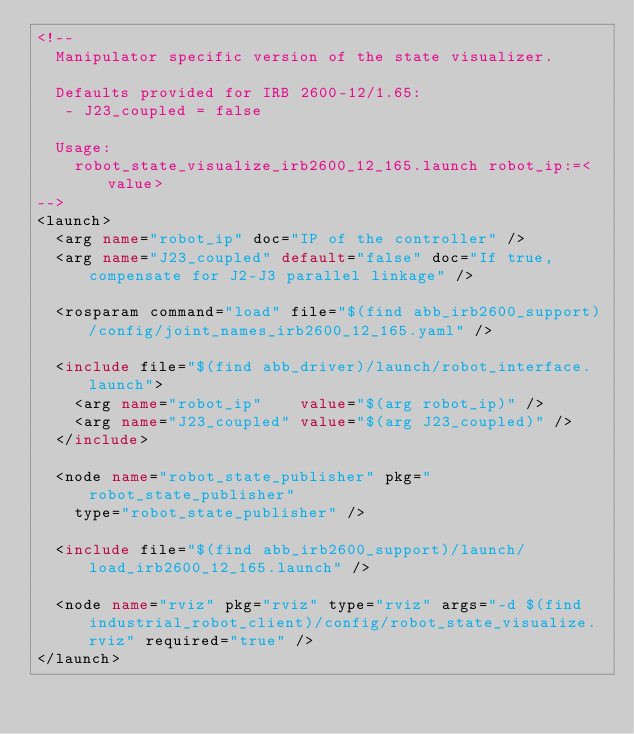<code> <loc_0><loc_0><loc_500><loc_500><_XML_><!--
  Manipulator specific version of the state visualizer.

  Defaults provided for IRB 2600-12/1.65:
   - J23_coupled = false

  Usage:
    robot_state_visualize_irb2600_12_165.launch robot_ip:=<value>
-->
<launch>
  <arg name="robot_ip" doc="IP of the controller" />
  <arg name="J23_coupled" default="false" doc="If true, compensate for J2-J3 parallel linkage" />

  <rosparam command="load" file="$(find abb_irb2600_support)/config/joint_names_irb2600_12_165.yaml" />

  <include file="$(find abb_driver)/launch/robot_interface.launch">
    <arg name="robot_ip"    value="$(arg robot_ip)" />
    <arg name="J23_coupled" value="$(arg J23_coupled)" />
  </include>

  <node name="robot_state_publisher" pkg="robot_state_publisher"
    type="robot_state_publisher" />

  <include file="$(find abb_irb2600_support)/launch/load_irb2600_12_165.launch" />

  <node name="rviz" pkg="rviz" type="rviz" args="-d $(find industrial_robot_client)/config/robot_state_visualize.rviz" required="true" />
</launch>
</code> 